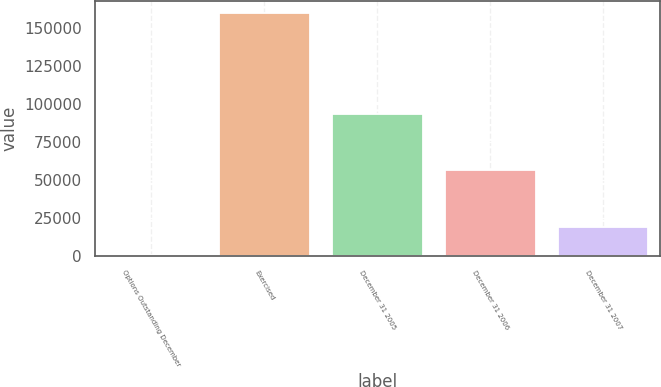<chart> <loc_0><loc_0><loc_500><loc_500><bar_chart><fcel>Options Outstanding December<fcel>Exercised<fcel>December 31 2005<fcel>December 31 2006<fcel>December 31 2007<nl><fcel>768<fcel>159638<fcel>93515<fcel>56416.2<fcel>19317.4<nl></chart> 